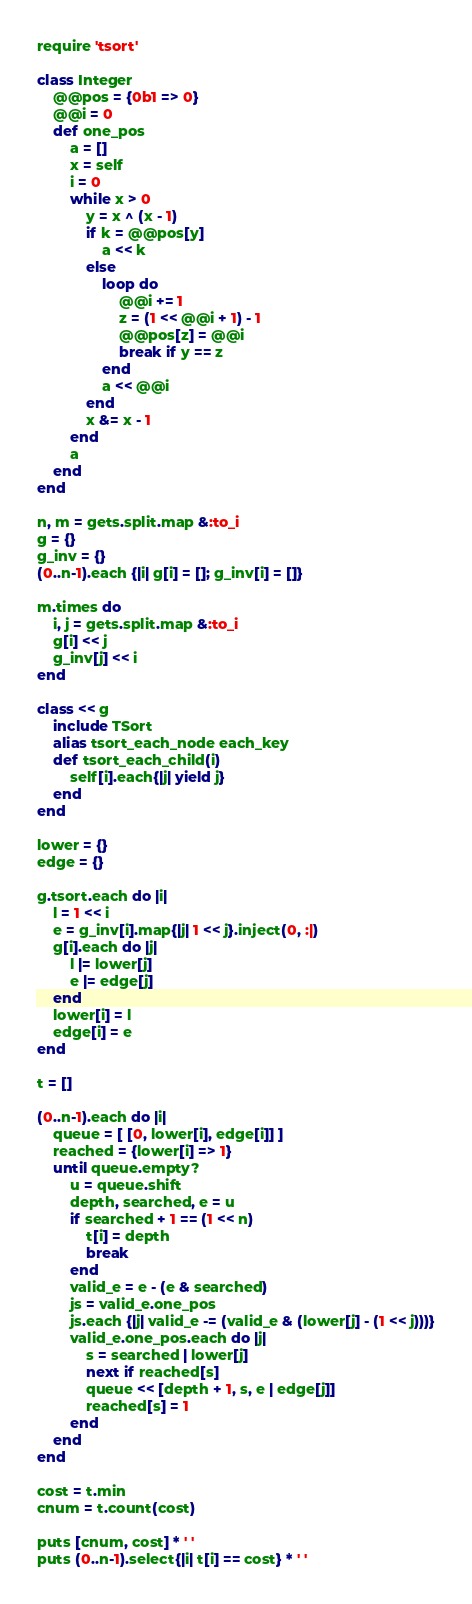<code> <loc_0><loc_0><loc_500><loc_500><_Ruby_>require 'tsort'

class Integer
	@@pos = {0b1 => 0}
	@@i = 0
	def one_pos
		a = []
		x = self
		i = 0
		while x > 0
			y = x ^ (x - 1)
			if k = @@pos[y]
				a << k
			else
				loop do
					@@i += 1
					z = (1 << @@i + 1) - 1
					@@pos[z] = @@i
					break if y == z
				end
				a << @@i
			end
			x &= x - 1
		end
		a
	end
end

n, m = gets.split.map &:to_i
g = {}
g_inv = {}
(0..n-1).each {|i| g[i] = []; g_inv[i] = []}

m.times do
	i, j = gets.split.map &:to_i
	g[i] << j
	g_inv[j] << i
end

class << g
	include TSort
	alias tsort_each_node each_key
	def tsort_each_child(i)
		self[i].each{|j| yield j}
	end
end

lower = {}
edge = {}

g.tsort.each do |i|
	l = 1 << i
	e = g_inv[i].map{|j| 1 << j}.inject(0, :|)
	g[i].each do |j|
		l |= lower[j]
		e |= edge[j]
	end
	lower[i] = l
	edge[i] = e
end

t = []

(0..n-1).each do |i|
	queue = [ [0, lower[i], edge[i]] ]
	reached = {lower[i] => 1}
	until queue.empty?
		u = queue.shift
		depth, searched, e = u
		if searched + 1 == (1 << n)
			t[i] = depth
			break
		end
		valid_e = e - (e & searched)
		js = valid_e.one_pos
		js.each {|j| valid_e -= (valid_e & (lower[j] - (1 << j)))}
		valid_e.one_pos.each do |j|
			s = searched | lower[j]
			next if reached[s]
			queue << [depth + 1, s, e | edge[j]]
			reached[s] = 1
		end
	end
end

cost = t.min
cnum = t.count(cost)

puts [cnum, cost] * ' '
puts (0..n-1).select{|i| t[i] == cost} * ' '</code> 